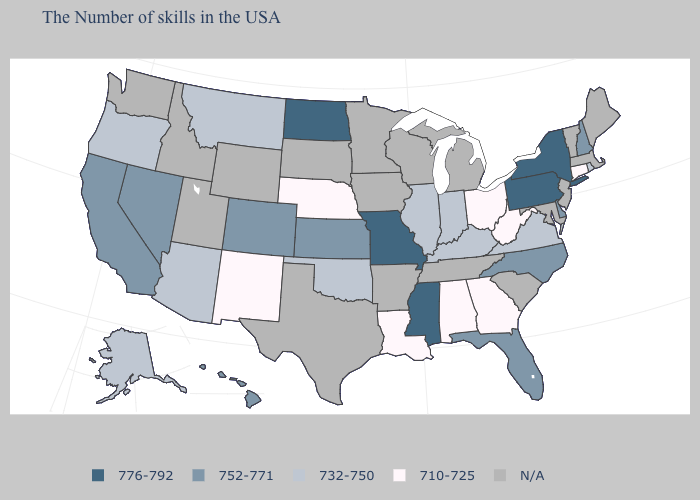Name the states that have a value in the range 732-750?
Answer briefly. Rhode Island, Virginia, Kentucky, Indiana, Illinois, Oklahoma, Montana, Arizona, Oregon, Alaska. What is the highest value in the USA?
Be succinct. 776-792. Name the states that have a value in the range 710-725?
Keep it brief. Connecticut, West Virginia, Ohio, Georgia, Alabama, Louisiana, Nebraska, New Mexico. Name the states that have a value in the range 752-771?
Concise answer only. New Hampshire, Delaware, North Carolina, Florida, Kansas, Colorado, Nevada, California, Hawaii. Is the legend a continuous bar?
Concise answer only. No. Does the map have missing data?
Give a very brief answer. Yes. Does Colorado have the highest value in the West?
Be succinct. Yes. What is the value of Illinois?
Short answer required. 732-750. How many symbols are there in the legend?
Quick response, please. 5. Name the states that have a value in the range 776-792?
Write a very short answer. New York, Pennsylvania, Mississippi, Missouri, North Dakota. Among the states that border Vermont , does New York have the highest value?
Be succinct. Yes. What is the lowest value in the South?
Write a very short answer. 710-725. 